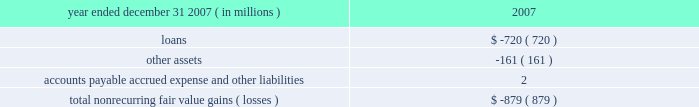Jpmorgan chase & co .
/ 2007 annual report 117 nonrecurring fair value changes the table presents the total change in value of financial instruments for which a fair value adjustment has been included in the consolidated statement of income for the year ended december 31 , 2007 , related to financial instruments held at december 31 , 2007 .
Year ended december 31 , 2007 ( in millions ) 2007 .
In the above table , loans principally include changes in fair value for loans carried on the balance sheet at the lower of cost or fair value ; and accounts payable , accrued expense and other liabilities principally includes the change in fair value for unfunded lending-related commitments within the leveraged lending portfolio .
Level 3 assets analysis level 3 assets ( including assets measured at the lower of cost or fair value ) were 5% ( 5 % ) of total firm assets at december 31 , 2007 .
These assets increased during 2007 principally during the second half of the year , when liquidity in mortgages and other credit products fell dra- matically .
The increase was primarily due to an increase in leveraged loan balances within level 3 as the ability of the firm to syndicate this risk to third parties became limited by the credit environment .
In addi- tion , there were transfers from level 2 to level 3 during 2007 .
These transfers were principally for instruments within the mortgage market where inputs which are significant to their valuation became unob- servable during the year .
Subprime and alt-a whole loans , subprime home equity securities , commercial mortgage-backed mezzanine loans and credit default swaps referenced to asset-backed securities consti- tuted the majority of the affected instruments , reflecting a significant decline in liquidity in these instruments in the third and fourth quarters of 2007 , as new issue activity was nonexistent and independent pric- ing information was no longer available for these assets .
Transition in connection with the initial adoption of sfas 157 , the firm recorded the following on january 1 , 2007 : 2022 a cumulative effect increase to retained earnings of $ 287 million , primarily related to the release of profit previously deferred in accordance with eitf 02-3 ; 2022 an increase to pretax income of $ 166 million ( $ 103 million after-tax ) related to the incorporation of the firm 2019s creditworthiness in the valuation of liabilities recorded at fair value ; and 2022 an increase to pretax income of $ 464 million ( $ 288 million after-tax ) related to valuations of nonpublic private equity investments .
Prior to the adoption of sfas 157 , the firm applied the provisions of eitf 02-3 to its derivative portfolio .
Eitf 02-3 precluded the recogni- tion of initial trading profit in the absence of : ( a ) quoted market prices , ( b ) observable prices of other current market transactions or ( c ) other observable data supporting a valuation technique .
In accor- dance with eitf 02-3 , the firm recognized the deferred profit in principal transactions revenue on a systematic basis ( typically straight- line amortization over the life of the instruments ) and when observ- able market data became available .
Prior to the adoption of sfas 157 the firm did not incorporate an adjustment into the valuation of liabilities carried at fair value on the consolidated balance sheet .
Commencing january 1 , 2007 , in accor- dance with the requirements of sfas 157 , an adjustment was made to the valuation of liabilities measured at fair value to reflect the credit quality of the firm .
Prior to the adoption of sfas 157 , privately held investments were initially valued based upon cost .
The carrying values of privately held investments were adjusted from cost to reflect both positive and neg- ative changes evidenced by financing events with third-party capital providers .
The investments were also subject to ongoing impairment reviews by private equity senior investment professionals .
The increase in pretax income related to nonpublic private equity investments in connection with the adoption of sfas 157 was due to there being sufficient market evidence to support an increase in fair values using the sfas 157 methodology , although there had not been an actual third-party market transaction related to such investments .
Financial disclosures required by sfas 107 sfas 107 requires disclosure of the estimated fair value of certain financial instruments and the methods and significant assumptions used to estimate their fair values .
Many but not all of the financial instruments held by the firm are recorded at fair value on the consolidated balance sheets .
Financial instruments within the scope of sfas 107 that are not carried at fair value on the consolidated balance sheets are discussed below .
Additionally , certain financial instruments and all nonfinancial instruments are excluded from the scope of sfas 107 .
Accordingly , the fair value disclosures required by sfas 107 provide only a partial estimate of the fair value of jpmorgan chase .
For example , the firm has developed long-term relationships with its customers through its deposit base and credit card accounts , commonly referred to as core deposit intangibles and credit card relationships .
In the opinion of management , these items , in the aggregate , add significant value to jpmorgan chase , but their fair value is not disclosed in this note .
Financial instruments for which fair value approximates carrying value certain financial instruments that are not carried at fair value on the consolidated balance sheets are carried at amounts that approxi- mate fair value due to their short-term nature and generally negligi- ble credit risk .
These instruments include cash and due from banks , deposits with banks , federal funds sold , securities purchased under resale agreements with short-dated maturities , securities borrowed , short-term receivables and accrued interest receivable , commercial paper , federal funds purchased , securities sold under repurchase agreements with short-dated maturities , other borrowed funds , accounts payable and accrued liabilities .
In addition , sfas 107 requires that the fair value for deposit liabilities with no stated matu- rity ( i.e. , demand , savings and certain money market deposits ) be equal to their carrying value .
Sfas 107 does not allow for the recog- nition of the inherent funding value of these instruments. .
Loan fv changes made up how much of the total nonrecurring fair value losses? 
Computations: (720 / 879)
Answer: 0.81911. Jpmorgan chase & co .
/ 2007 annual report 117 nonrecurring fair value changes the table presents the total change in value of financial instruments for which a fair value adjustment has been included in the consolidated statement of income for the year ended december 31 , 2007 , related to financial instruments held at december 31 , 2007 .
Year ended december 31 , 2007 ( in millions ) 2007 .
In the above table , loans principally include changes in fair value for loans carried on the balance sheet at the lower of cost or fair value ; and accounts payable , accrued expense and other liabilities principally includes the change in fair value for unfunded lending-related commitments within the leveraged lending portfolio .
Level 3 assets analysis level 3 assets ( including assets measured at the lower of cost or fair value ) were 5% ( 5 % ) of total firm assets at december 31 , 2007 .
These assets increased during 2007 principally during the second half of the year , when liquidity in mortgages and other credit products fell dra- matically .
The increase was primarily due to an increase in leveraged loan balances within level 3 as the ability of the firm to syndicate this risk to third parties became limited by the credit environment .
In addi- tion , there were transfers from level 2 to level 3 during 2007 .
These transfers were principally for instruments within the mortgage market where inputs which are significant to their valuation became unob- servable during the year .
Subprime and alt-a whole loans , subprime home equity securities , commercial mortgage-backed mezzanine loans and credit default swaps referenced to asset-backed securities consti- tuted the majority of the affected instruments , reflecting a significant decline in liquidity in these instruments in the third and fourth quarters of 2007 , as new issue activity was nonexistent and independent pric- ing information was no longer available for these assets .
Transition in connection with the initial adoption of sfas 157 , the firm recorded the following on january 1 , 2007 : 2022 a cumulative effect increase to retained earnings of $ 287 million , primarily related to the release of profit previously deferred in accordance with eitf 02-3 ; 2022 an increase to pretax income of $ 166 million ( $ 103 million after-tax ) related to the incorporation of the firm 2019s creditworthiness in the valuation of liabilities recorded at fair value ; and 2022 an increase to pretax income of $ 464 million ( $ 288 million after-tax ) related to valuations of nonpublic private equity investments .
Prior to the adoption of sfas 157 , the firm applied the provisions of eitf 02-3 to its derivative portfolio .
Eitf 02-3 precluded the recogni- tion of initial trading profit in the absence of : ( a ) quoted market prices , ( b ) observable prices of other current market transactions or ( c ) other observable data supporting a valuation technique .
In accor- dance with eitf 02-3 , the firm recognized the deferred profit in principal transactions revenue on a systematic basis ( typically straight- line amortization over the life of the instruments ) and when observ- able market data became available .
Prior to the adoption of sfas 157 the firm did not incorporate an adjustment into the valuation of liabilities carried at fair value on the consolidated balance sheet .
Commencing january 1 , 2007 , in accor- dance with the requirements of sfas 157 , an adjustment was made to the valuation of liabilities measured at fair value to reflect the credit quality of the firm .
Prior to the adoption of sfas 157 , privately held investments were initially valued based upon cost .
The carrying values of privately held investments were adjusted from cost to reflect both positive and neg- ative changes evidenced by financing events with third-party capital providers .
The investments were also subject to ongoing impairment reviews by private equity senior investment professionals .
The increase in pretax income related to nonpublic private equity investments in connection with the adoption of sfas 157 was due to there being sufficient market evidence to support an increase in fair values using the sfas 157 methodology , although there had not been an actual third-party market transaction related to such investments .
Financial disclosures required by sfas 107 sfas 107 requires disclosure of the estimated fair value of certain financial instruments and the methods and significant assumptions used to estimate their fair values .
Many but not all of the financial instruments held by the firm are recorded at fair value on the consolidated balance sheets .
Financial instruments within the scope of sfas 107 that are not carried at fair value on the consolidated balance sheets are discussed below .
Additionally , certain financial instruments and all nonfinancial instruments are excluded from the scope of sfas 107 .
Accordingly , the fair value disclosures required by sfas 107 provide only a partial estimate of the fair value of jpmorgan chase .
For example , the firm has developed long-term relationships with its customers through its deposit base and credit card accounts , commonly referred to as core deposit intangibles and credit card relationships .
In the opinion of management , these items , in the aggregate , add significant value to jpmorgan chase , but their fair value is not disclosed in this note .
Financial instruments for which fair value approximates carrying value certain financial instruments that are not carried at fair value on the consolidated balance sheets are carried at amounts that approxi- mate fair value due to their short-term nature and generally negligi- ble credit risk .
These instruments include cash and due from banks , deposits with banks , federal funds sold , securities purchased under resale agreements with short-dated maturities , securities borrowed , short-term receivables and accrued interest receivable , commercial paper , federal funds purchased , securities sold under repurchase agreements with short-dated maturities , other borrowed funds , accounts payable and accrued liabilities .
In addition , sfas 107 requires that the fair value for deposit liabilities with no stated matu- rity ( i.e. , demand , savings and certain money market deposits ) be equal to their carrying value .
Sfas 107 does not allow for the recog- nition of the inherent funding value of these instruments. .
In 2007 what was the ratio of the changes in loans to other assets? 
Computations: (720 / 161)
Answer: 4.47205. 